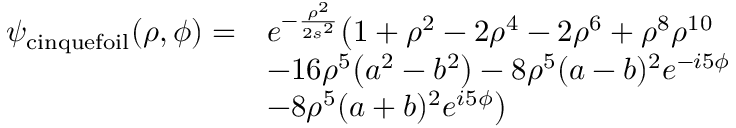Convert formula to latex. <formula><loc_0><loc_0><loc_500><loc_500>\begin{array} { r l } { \psi _ { c i n q u e f o i l } ( \rho , \phi ) = } & { e ^ { - \frac { \rho ^ { 2 } } { 2 s ^ { 2 } } } \left ( 1 + \rho ^ { 2 } - 2 \rho ^ { 4 } - 2 \rho ^ { 6 } + \rho ^ { 8 } \rho ^ { 1 0 } } \\ & { - 1 6 \rho ^ { 5 } \left ( a ^ { 2 } - b ^ { 2 } \right ) - 8 \rho ^ { 5 } ( a - b ) ^ { 2 } e ^ { - i 5 \phi } } \\ & { - 8 \rho ^ { 5 } ( a + b ) ^ { 2 } e ^ { i 5 \phi } \right ) } \end{array}</formula> 